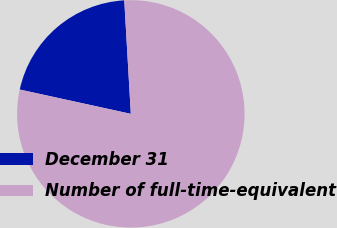Convert chart to OTSL. <chart><loc_0><loc_0><loc_500><loc_500><pie_chart><fcel>December 31<fcel>Number of full-time-equivalent<nl><fcel>20.65%<fcel>79.35%<nl></chart> 